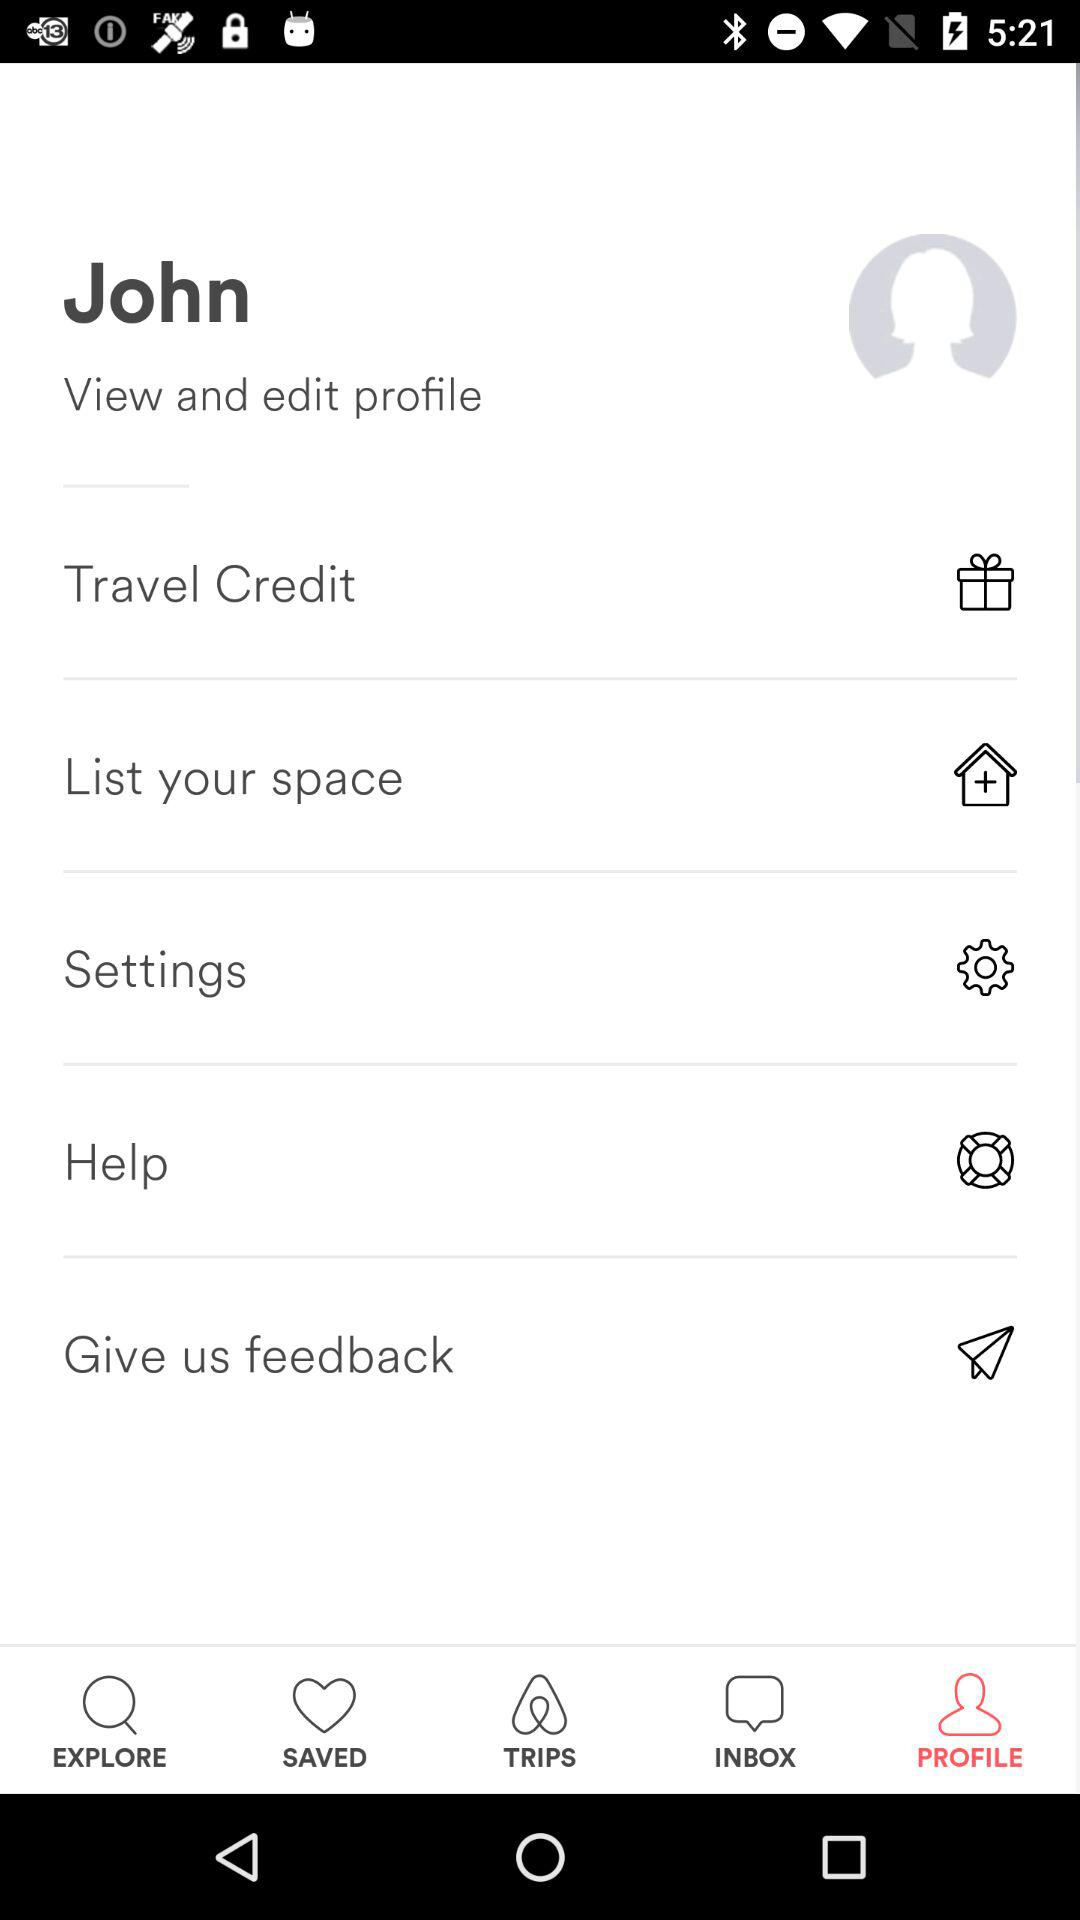What is the selected tab? The selected tab is "PROFILE". 